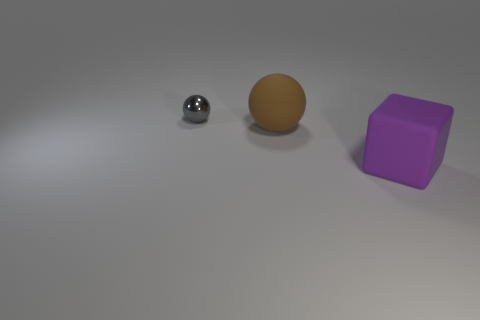What might the different textures and shapes represent in a symbolic interpretation? In a symbolic interpretation, the various textures and shapes could represent diversity and contrast in unity. The reflective sphere could signify technology or modernity, the matte ball can be seen as nature or simplicity, and the cube might stand for stability and order. The arrangement coexisting peacefully could symbolize harmony among different elements or ideas. 